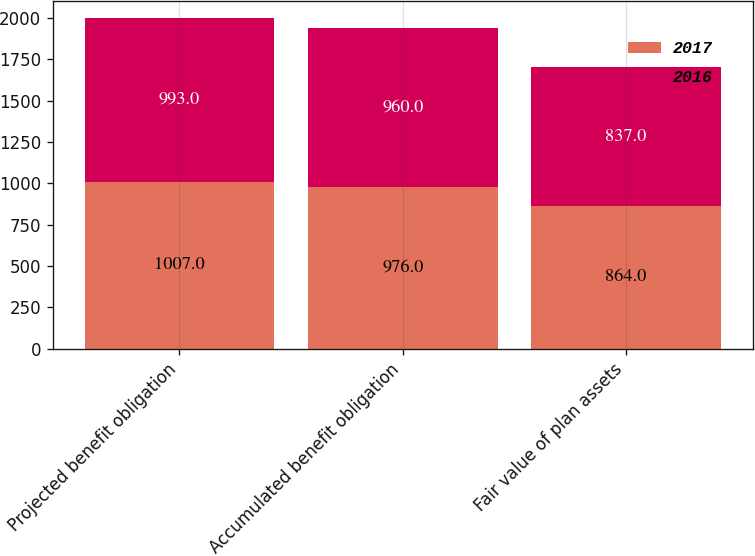Convert chart to OTSL. <chart><loc_0><loc_0><loc_500><loc_500><stacked_bar_chart><ecel><fcel>Projected benefit obligation<fcel>Accumulated benefit obligation<fcel>Fair value of plan assets<nl><fcel>2017<fcel>1007<fcel>976<fcel>864<nl><fcel>2016<fcel>993<fcel>960<fcel>837<nl></chart> 